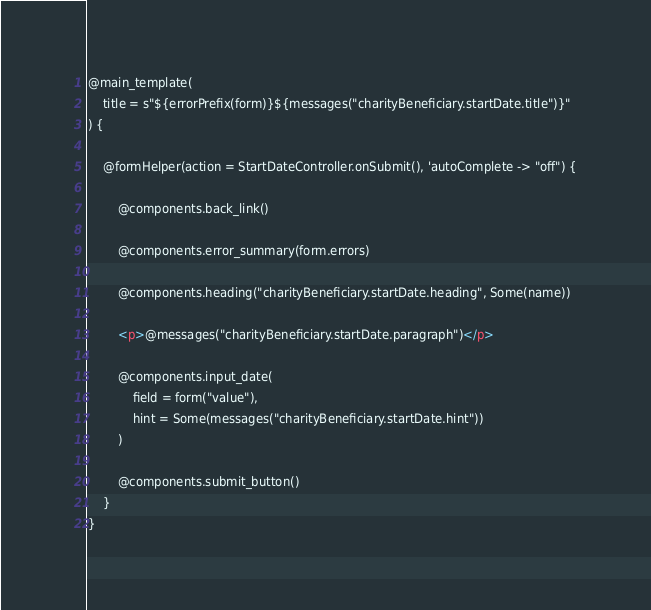Convert code to text. <code><loc_0><loc_0><loc_500><loc_500><_HTML_>
@main_template(
    title = s"${errorPrefix(form)}${messages("charityBeneficiary.startDate.title")}"
) {

    @formHelper(action = StartDateController.onSubmit(), 'autoComplete -> "off") {

        @components.back_link()

        @components.error_summary(form.errors)

        @components.heading("charityBeneficiary.startDate.heading", Some(name))

        <p>@messages("charityBeneficiary.startDate.paragraph")</p>

        @components.input_date(
            field = form("value"),
            hint = Some(messages("charityBeneficiary.startDate.hint"))
        )

        @components.submit_button()
    }
}
</code> 